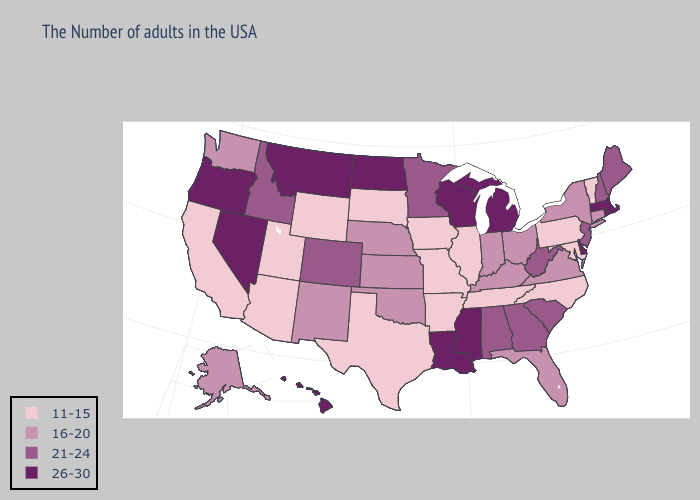Does Louisiana have the highest value in the USA?
Concise answer only. Yes. What is the highest value in states that border Kansas?
Short answer required. 21-24. Does Oregon have the highest value in the USA?
Keep it brief. Yes. Among the states that border Minnesota , does North Dakota have the lowest value?
Concise answer only. No. Name the states that have a value in the range 21-24?
Give a very brief answer. Maine, New Hampshire, New Jersey, South Carolina, West Virginia, Georgia, Alabama, Minnesota, Colorado, Idaho. What is the value of Tennessee?
Answer briefly. 11-15. What is the value of South Dakota?
Answer briefly. 11-15. Does Oregon have the same value as Kansas?
Give a very brief answer. No. Does the map have missing data?
Keep it brief. No. Among the states that border Illinois , does Wisconsin have the highest value?
Concise answer only. Yes. Which states have the lowest value in the South?
Answer briefly. Maryland, North Carolina, Tennessee, Arkansas, Texas. Name the states that have a value in the range 16-20?
Concise answer only. Connecticut, New York, Virginia, Ohio, Florida, Kentucky, Indiana, Kansas, Nebraska, Oklahoma, New Mexico, Washington, Alaska. Name the states that have a value in the range 26-30?
Quick response, please. Massachusetts, Rhode Island, Delaware, Michigan, Wisconsin, Mississippi, Louisiana, North Dakota, Montana, Nevada, Oregon, Hawaii. Among the states that border Idaho , does Utah have the lowest value?
Be succinct. Yes. Among the states that border Maryland , does Delaware have the highest value?
Concise answer only. Yes. 